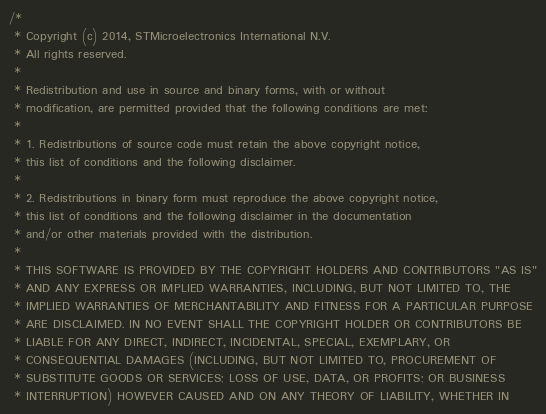Convert code to text. <code><loc_0><loc_0><loc_500><loc_500><_C_>/*
 * Copyright (c) 2014, STMicroelectronics International N.V.
 * All rights reserved.
 *
 * Redistribution and use in source and binary forms, with or without
 * modification, are permitted provided that the following conditions are met:
 *
 * 1. Redistributions of source code must retain the above copyright notice,
 * this list of conditions and the following disclaimer.
 *
 * 2. Redistributions in binary form must reproduce the above copyright notice,
 * this list of conditions and the following disclaimer in the documentation
 * and/or other materials provided with the distribution.
 *
 * THIS SOFTWARE IS PROVIDED BY THE COPYRIGHT HOLDERS AND CONTRIBUTORS "AS IS"
 * AND ANY EXPRESS OR IMPLIED WARRANTIES, INCLUDING, BUT NOT LIMITED TO, THE
 * IMPLIED WARRANTIES OF MERCHANTABILITY AND FITNESS FOR A PARTICULAR PURPOSE
 * ARE DISCLAIMED. IN NO EVENT SHALL THE COPYRIGHT HOLDER OR CONTRIBUTORS BE
 * LIABLE FOR ANY DIRECT, INDIRECT, INCIDENTAL, SPECIAL, EXEMPLARY, OR
 * CONSEQUENTIAL DAMAGES (INCLUDING, BUT NOT LIMITED TO, PROCUREMENT OF
 * SUBSTITUTE GOODS OR SERVICES; LOSS OF USE, DATA, OR PROFITS; OR BUSINESS
 * INTERRUPTION) HOWEVER CAUSED AND ON ANY THEORY OF LIABILITY, WHETHER IN</code> 